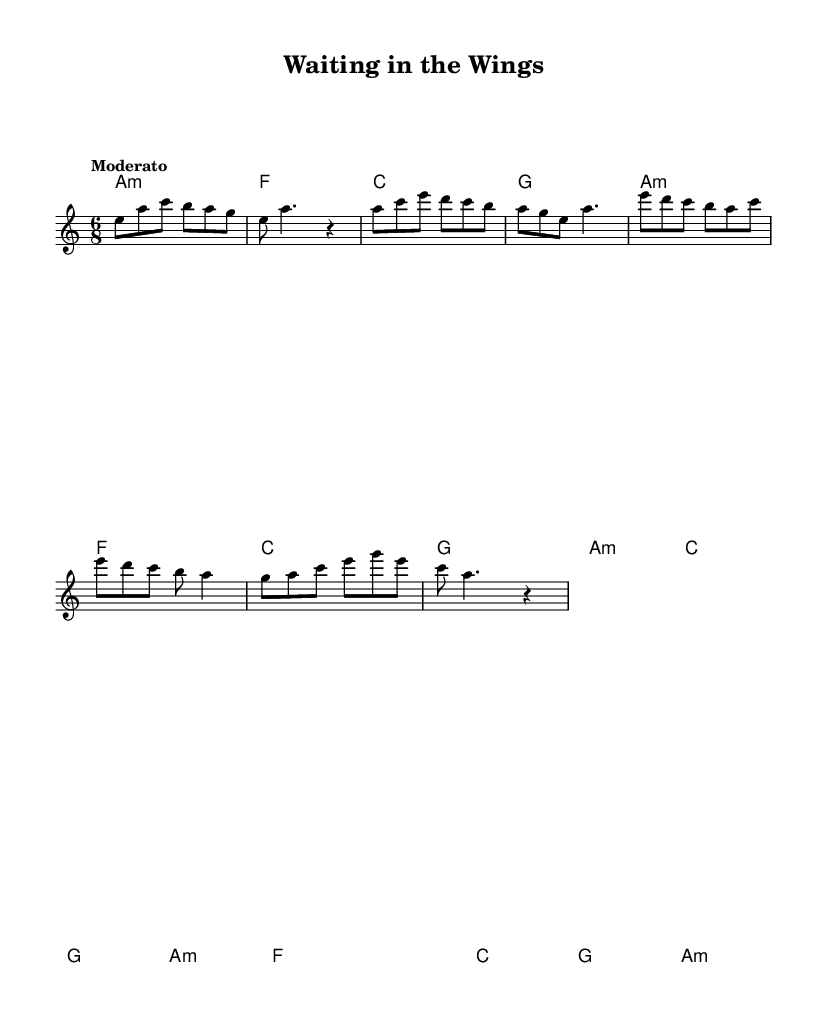What is the key signature of this music? The key signature is A minor, which has no sharps or flats, as indicated in the global definitions of the sheet music.
Answer: A minor What is the time signature of this music? The time signature is 6/8, indicating six beats per measure with each beat being an eighth note. This is stated in the global section of the code.
Answer: 6/8 What is the tempo marking of this music? The tempo marking states "Moderato," which indicates a moderate pace in the performance of the piece. This is noted in the global settings of the sheet music.
Answer: Moderato How many bars are there in the bridge section? The bridge section consists of four bars, as can be counted from the provided melody and harmonies within that segment of the music.
Answer: 4 What is the first chord played in the intro? The first chord in the intro is A minor, noted in the harmonies section, where the chord pattern starts with A minor.
Answer: A minor How many times does the chorus section repeat? The chorus section appears once in the provided code; it does not indicate any repetition of this section. The code layout shows it explicitly as a singular set.
Answer: 1 What is the emotional theme conveyed by this fusion music? The emotional theme conveyed in this African-blues fusion is the journey of aspiring actors waiting for their big break, as evident through the style and context of the lyrics and structure in the piece.
Answer: Aspiring actors 